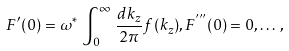Convert formula to latex. <formula><loc_0><loc_0><loc_500><loc_500>F ^ { \prime } ( 0 ) = \omega ^ { * } \, \int _ { 0 } ^ { \infty } \, \frac { d k _ { z } } { 2 \pi } f ( k _ { z } ) , F ^ { ^ { \prime \prime \prime } } ( 0 ) = 0 , \dots \, ,</formula> 